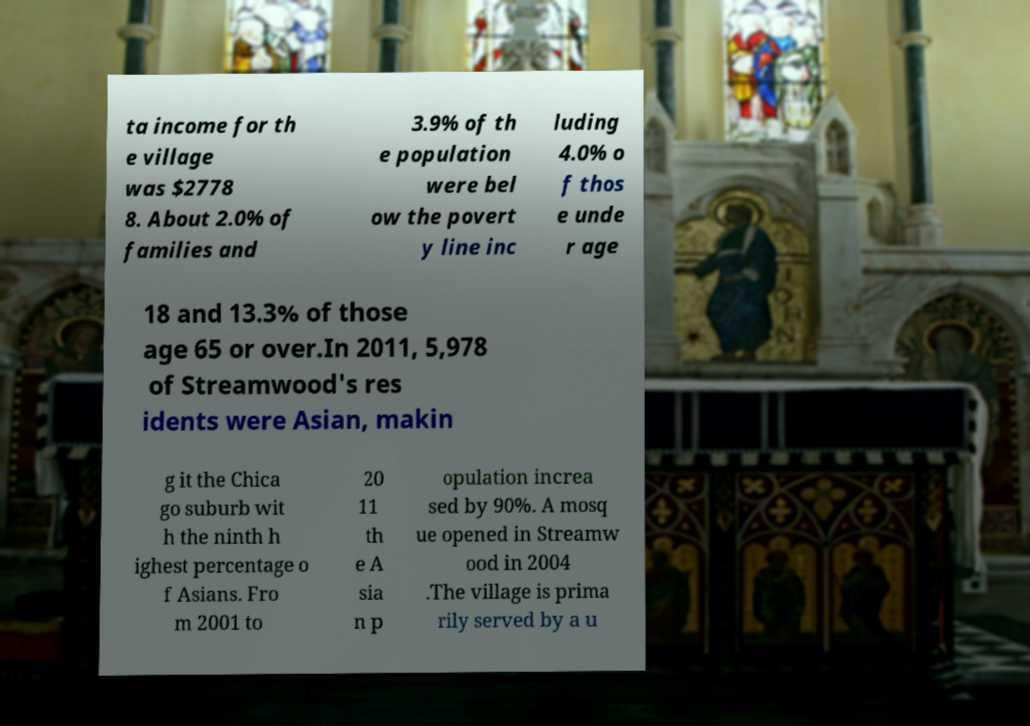For documentation purposes, I need the text within this image transcribed. Could you provide that? ta income for th e village was $2778 8. About 2.0% of families and 3.9% of th e population were bel ow the povert y line inc luding 4.0% o f thos e unde r age 18 and 13.3% of those age 65 or over.In 2011, 5,978 of Streamwood's res idents were Asian, makin g it the Chica go suburb wit h the ninth h ighest percentage o f Asians. Fro m 2001 to 20 11 th e A sia n p opulation increa sed by 90%. A mosq ue opened in Streamw ood in 2004 .The village is prima rily served by a u 